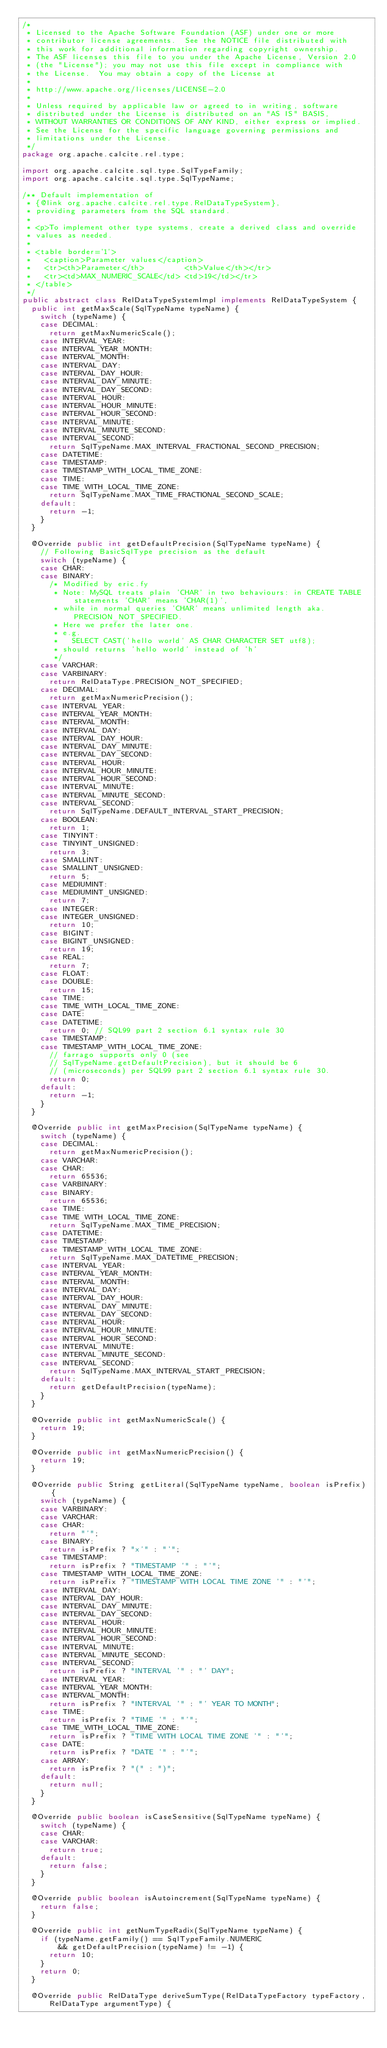<code> <loc_0><loc_0><loc_500><loc_500><_Java_>/*
 * Licensed to the Apache Software Foundation (ASF) under one or more
 * contributor license agreements.  See the NOTICE file distributed with
 * this work for additional information regarding copyright ownership.
 * The ASF licenses this file to you under the Apache License, Version 2.0
 * (the "License"); you may not use this file except in compliance with
 * the License.  You may obtain a copy of the License at
 *
 * http://www.apache.org/licenses/LICENSE-2.0
 *
 * Unless required by applicable law or agreed to in writing, software
 * distributed under the License is distributed on an "AS IS" BASIS,
 * WITHOUT WARRANTIES OR CONDITIONS OF ANY KIND, either express or implied.
 * See the License for the specific language governing permissions and
 * limitations under the License.
 */
package org.apache.calcite.rel.type;

import org.apache.calcite.sql.type.SqlTypeFamily;
import org.apache.calcite.sql.type.SqlTypeName;

/** Default implementation of
 * {@link org.apache.calcite.rel.type.RelDataTypeSystem},
 * providing parameters from the SQL standard.
 *
 * <p>To implement other type systems, create a derived class and override
 * values as needed.
 *
 * <table border='1'>
 *   <caption>Parameter values</caption>
 *   <tr><th>Parameter</th>         <th>Value</th></tr>
 *   <tr><td>MAX_NUMERIC_SCALE</td> <td>19</td></tr>
 * </table>
 */
public abstract class RelDataTypeSystemImpl implements RelDataTypeSystem {
  public int getMaxScale(SqlTypeName typeName) {
    switch (typeName) {
    case DECIMAL:
      return getMaxNumericScale();
    case INTERVAL_YEAR:
    case INTERVAL_YEAR_MONTH:
    case INTERVAL_MONTH:
    case INTERVAL_DAY:
    case INTERVAL_DAY_HOUR:
    case INTERVAL_DAY_MINUTE:
    case INTERVAL_DAY_SECOND:
    case INTERVAL_HOUR:
    case INTERVAL_HOUR_MINUTE:
    case INTERVAL_HOUR_SECOND:
    case INTERVAL_MINUTE:
    case INTERVAL_MINUTE_SECOND:
    case INTERVAL_SECOND:
      return SqlTypeName.MAX_INTERVAL_FRACTIONAL_SECOND_PRECISION;
    case DATETIME:
    case TIMESTAMP:
    case TIMESTAMP_WITH_LOCAL_TIME_ZONE:
    case TIME:
    case TIME_WITH_LOCAL_TIME_ZONE:
      return SqlTypeName.MAX_TIME_FRACTIONAL_SECOND_SCALE;
    default:
      return -1;
    }
  }

  @Override public int getDefaultPrecision(SqlTypeName typeName) {
    // Following BasicSqlType precision as the default
    switch (typeName) {
    case CHAR:
    case BINARY:
      /* Modified by eric.fy
       * Note: MySQL treats plain 'CHAR' in two behaviours: in CREATE TABLE statements 'CHAR' means 'CHAR(1)',
       * while in normal queries 'CHAR' means unlimited length aka. PRECISION_NOT_SPECIFIED.
       * Here we prefer the later one.
       * e.g.
       *   SELECT CAST('hello world' AS CHAR CHARACTER SET utf8);
       * should returns 'hello world' instead of 'h'
       */
    case VARCHAR:
    case VARBINARY:
      return RelDataType.PRECISION_NOT_SPECIFIED;
    case DECIMAL:
      return getMaxNumericPrecision();
    case INTERVAL_YEAR:
    case INTERVAL_YEAR_MONTH:
    case INTERVAL_MONTH:
    case INTERVAL_DAY:
    case INTERVAL_DAY_HOUR:
    case INTERVAL_DAY_MINUTE:
    case INTERVAL_DAY_SECOND:
    case INTERVAL_HOUR:
    case INTERVAL_HOUR_MINUTE:
    case INTERVAL_HOUR_SECOND:
    case INTERVAL_MINUTE:
    case INTERVAL_MINUTE_SECOND:
    case INTERVAL_SECOND:
      return SqlTypeName.DEFAULT_INTERVAL_START_PRECISION;
    case BOOLEAN:
      return 1;
    case TINYINT:
    case TINYINT_UNSIGNED:
      return 3;
    case SMALLINT:
    case SMALLINT_UNSIGNED:
      return 5;
    case MEDIUMINT:
    case MEDIUMINT_UNSIGNED:
      return 7;
    case INTEGER:
    case INTEGER_UNSIGNED:
      return 10;
    case BIGINT:
    case BIGINT_UNSIGNED:
      return 19;
    case REAL:
      return 7;
    case FLOAT:
    case DOUBLE:
      return 15;
    case TIME:
    case TIME_WITH_LOCAL_TIME_ZONE:
    case DATE:
    case DATETIME:
      return 0; // SQL99 part 2 section 6.1 syntax rule 30
    case TIMESTAMP:
    case TIMESTAMP_WITH_LOCAL_TIME_ZONE:
      // farrago supports only 0 (see
      // SqlTypeName.getDefaultPrecision), but it should be 6
      // (microseconds) per SQL99 part 2 section 6.1 syntax rule 30.
      return 0;
    default:
      return -1;
    }
  }

  @Override public int getMaxPrecision(SqlTypeName typeName) {
    switch (typeName) {
    case DECIMAL:
      return getMaxNumericPrecision();
    case VARCHAR:
    case CHAR:
      return 65536;
    case VARBINARY:
    case BINARY:
      return 65536;
    case TIME:
    case TIME_WITH_LOCAL_TIME_ZONE:
      return SqlTypeName.MAX_TIME_PRECISION;
    case DATETIME:
    case TIMESTAMP:
    case TIMESTAMP_WITH_LOCAL_TIME_ZONE:
      return SqlTypeName.MAX_DATETIME_PRECISION;
    case INTERVAL_YEAR:
    case INTERVAL_YEAR_MONTH:
    case INTERVAL_MONTH:
    case INTERVAL_DAY:
    case INTERVAL_DAY_HOUR:
    case INTERVAL_DAY_MINUTE:
    case INTERVAL_DAY_SECOND:
    case INTERVAL_HOUR:
    case INTERVAL_HOUR_MINUTE:
    case INTERVAL_HOUR_SECOND:
    case INTERVAL_MINUTE:
    case INTERVAL_MINUTE_SECOND:
    case INTERVAL_SECOND:
      return SqlTypeName.MAX_INTERVAL_START_PRECISION;
    default:
      return getDefaultPrecision(typeName);
    }
  }

  @Override public int getMaxNumericScale() {
    return 19;
  }

  @Override public int getMaxNumericPrecision() {
    return 19;
  }

  @Override public String getLiteral(SqlTypeName typeName, boolean isPrefix) {
    switch (typeName) {
    case VARBINARY:
    case VARCHAR:
    case CHAR:
      return "'";
    case BINARY:
      return isPrefix ? "x'" : "'";
    case TIMESTAMP:
      return isPrefix ? "TIMESTAMP '" : "'";
    case TIMESTAMP_WITH_LOCAL_TIME_ZONE:
      return isPrefix ? "TIMESTAMP WITH LOCAL TIME ZONE '" : "'";
    case INTERVAL_DAY:
    case INTERVAL_DAY_HOUR:
    case INTERVAL_DAY_MINUTE:
    case INTERVAL_DAY_SECOND:
    case INTERVAL_HOUR:
    case INTERVAL_HOUR_MINUTE:
    case INTERVAL_HOUR_SECOND:
    case INTERVAL_MINUTE:
    case INTERVAL_MINUTE_SECOND:
    case INTERVAL_SECOND:
      return isPrefix ? "INTERVAL '" : "' DAY";
    case INTERVAL_YEAR:
    case INTERVAL_YEAR_MONTH:
    case INTERVAL_MONTH:
      return isPrefix ? "INTERVAL '" : "' YEAR TO MONTH";
    case TIME:
      return isPrefix ? "TIME '" : "'";
    case TIME_WITH_LOCAL_TIME_ZONE:
      return isPrefix ? "TIME WITH LOCAL TIME ZONE '" : "'";
    case DATE:
      return isPrefix ? "DATE '" : "'";
    case ARRAY:
      return isPrefix ? "(" : ")";
    default:
      return null;
    }
  }

  @Override public boolean isCaseSensitive(SqlTypeName typeName) {
    switch (typeName) {
    case CHAR:
    case VARCHAR:
      return true;
    default:
      return false;
    }
  }

  @Override public boolean isAutoincrement(SqlTypeName typeName) {
    return false;
  }

  @Override public int getNumTypeRadix(SqlTypeName typeName) {
    if (typeName.getFamily() == SqlTypeFamily.NUMERIC
        && getDefaultPrecision(typeName) != -1) {
      return 10;
    }
    return 0;
  }

  @Override public RelDataType deriveSumType(RelDataTypeFactory typeFactory,
      RelDataType argumentType) {</code> 